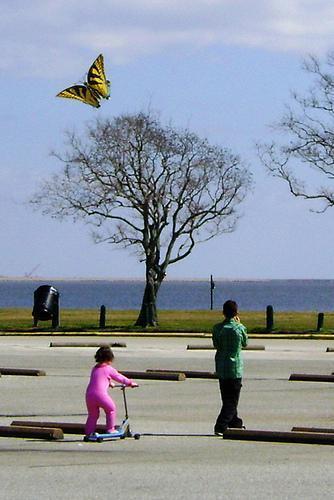How many scooters are in the picture?
Give a very brief answer. 1. How many people are in this photo?
Give a very brief answer. 2. How many kids do you see?
Give a very brief answer. 2. 